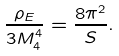Convert formula to latex. <formula><loc_0><loc_0><loc_500><loc_500>\frac { \rho _ { E } } { 3 M _ { 4 } ^ { 4 } } = \frac { 8 \pi ^ { 2 } } { S } .</formula> 